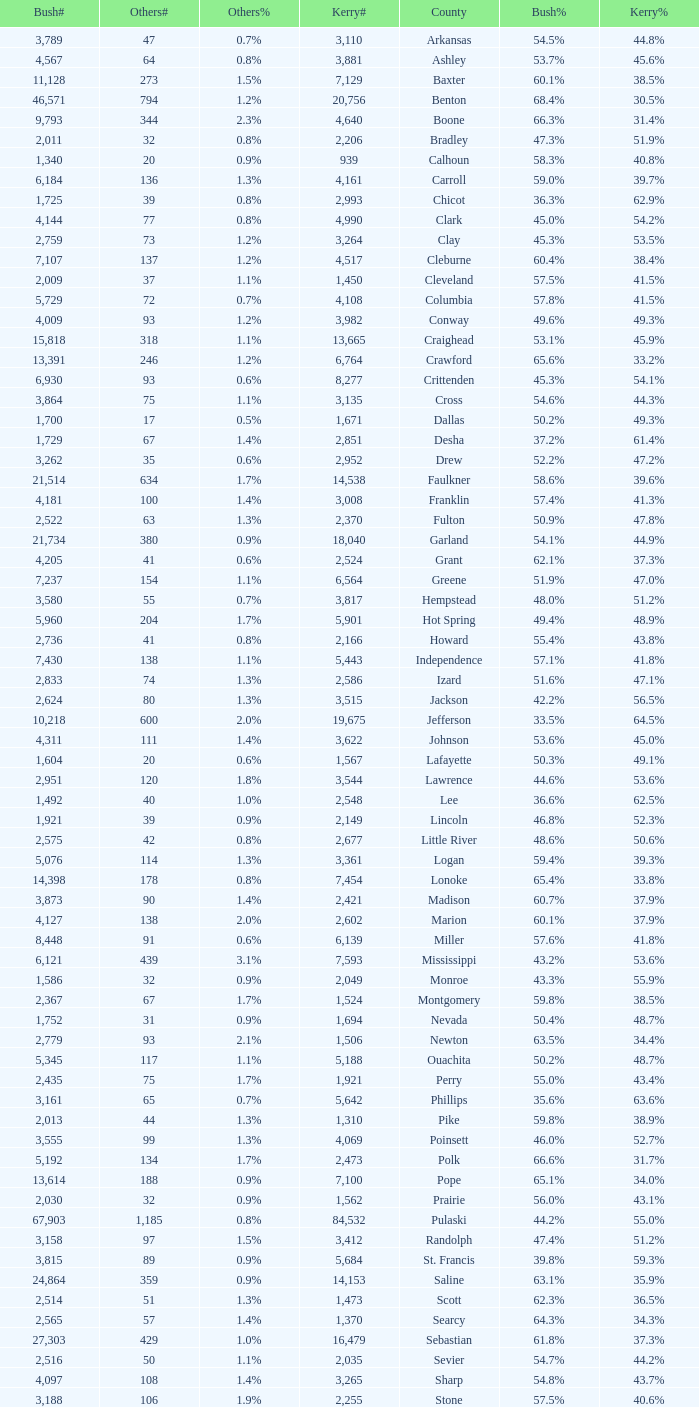What is the highest Bush#, when Others% is "1.7%", when Others# is less than 75, and when Kerry# is greater than 1,524? None. 